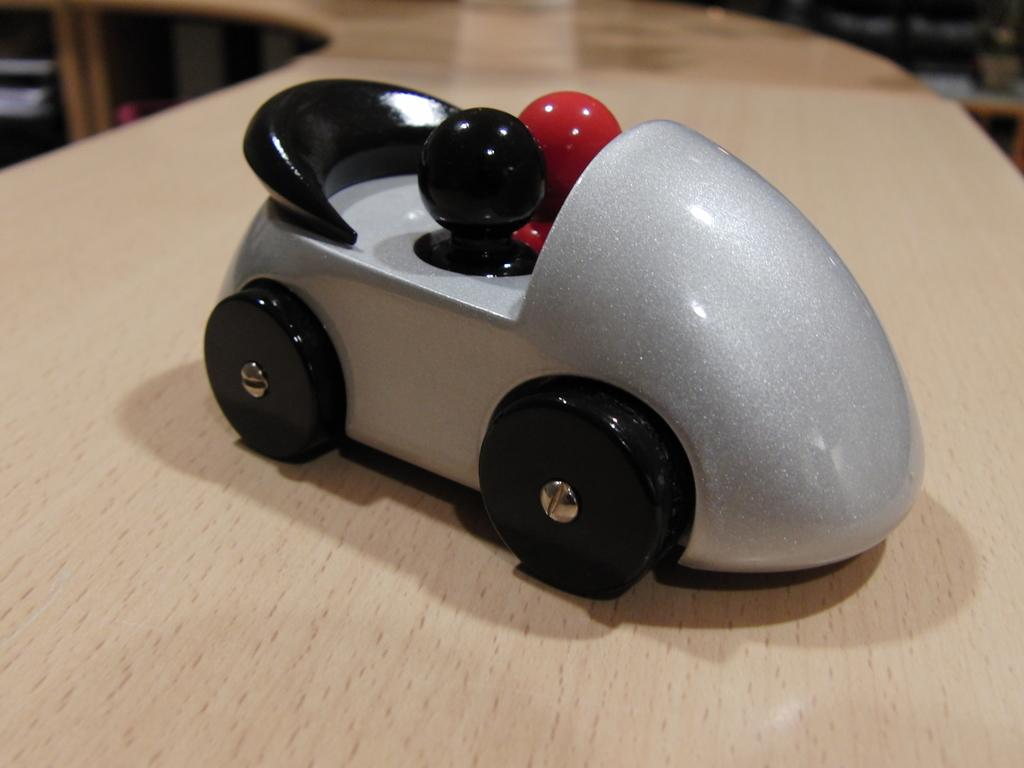What is the main subject of the image? The main subject of the image is a toy car. Where is the toy car located in the image? The toy car is on a table. What type of game is being played with the toy car in the image? There is no indication in the image that a game is being played with the toy car. Can you tell me how many pears are visible in the image? There are no pears present in the image. What kind of apparatus is used to control the toy car in the image? There is no apparatus visible in the image; the toy car is likely being controlled manually. 